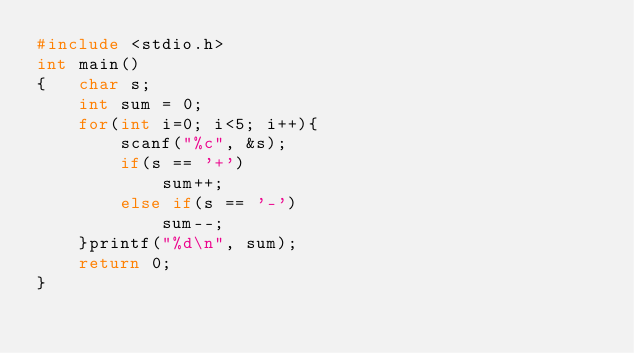Convert code to text. <code><loc_0><loc_0><loc_500><loc_500><_C_>#include <stdio.h>
int main()
{	char s;
    int sum = 0;
    for(int i=0; i<5; i++){
        scanf("%c", &s);
        if(s == '+')
            sum++;
        else if(s == '-')
            sum--;
    }printf("%d\n", sum);
    return 0;
}</code> 